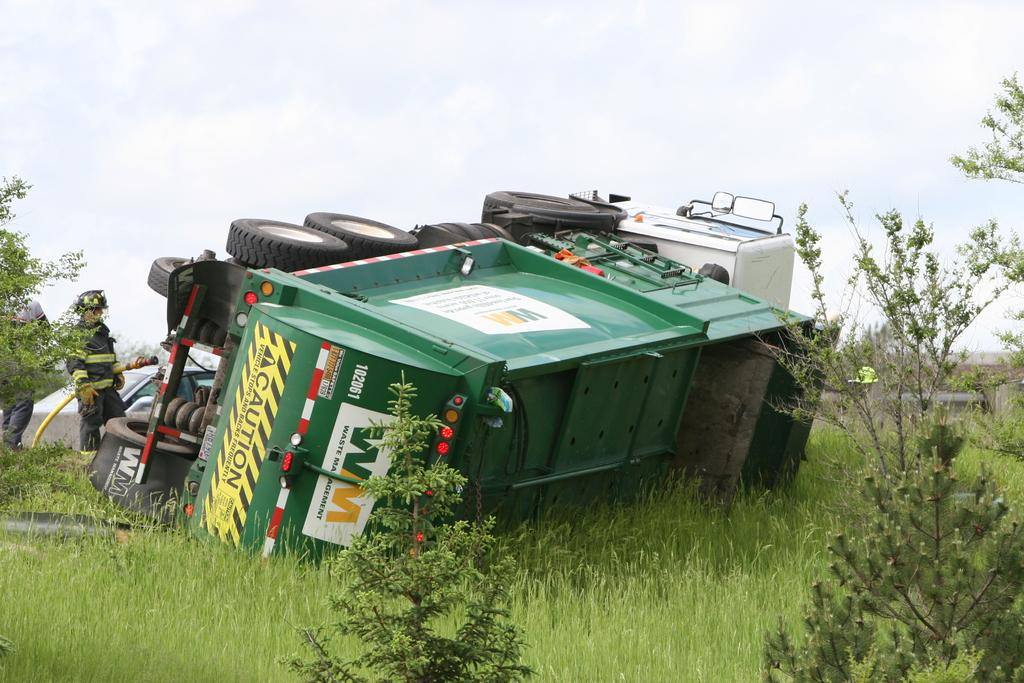What is the main subject of the image? The main subject of the image is a truck. What else can be seen in the image besides the truck? There are plants and grass in the image. Is there any indication of human presence in the image? Yes, there is a person standing in the image. What can be seen in the background of the image? The sky is visible in the image. What type of corn can be seen growing in the image? There is no corn present in the image; it features a truck, plants, grass, a person, and the sky. 